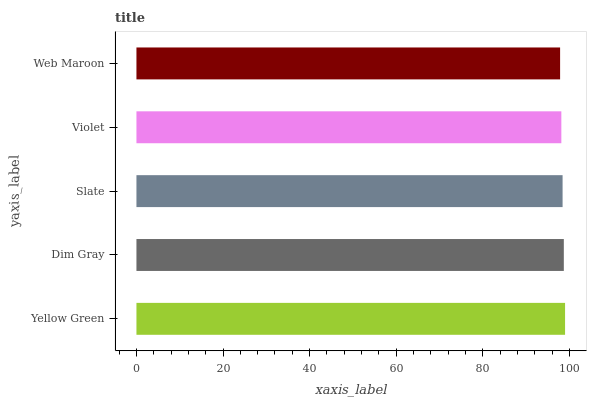Is Web Maroon the minimum?
Answer yes or no. Yes. Is Yellow Green the maximum?
Answer yes or no. Yes. Is Dim Gray the minimum?
Answer yes or no. No. Is Dim Gray the maximum?
Answer yes or no. No. Is Yellow Green greater than Dim Gray?
Answer yes or no. Yes. Is Dim Gray less than Yellow Green?
Answer yes or no. Yes. Is Dim Gray greater than Yellow Green?
Answer yes or no. No. Is Yellow Green less than Dim Gray?
Answer yes or no. No. Is Slate the high median?
Answer yes or no. Yes. Is Slate the low median?
Answer yes or no. Yes. Is Yellow Green the high median?
Answer yes or no. No. Is Dim Gray the low median?
Answer yes or no. No. 